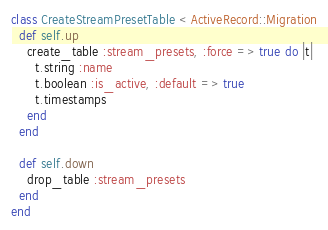Convert code to text. <code><loc_0><loc_0><loc_500><loc_500><_Ruby_>class CreateStreamPresetTable < ActiveRecord::Migration
  def self.up
    create_table :stream_presets, :force => true do |t|
      t.string :name
      t.boolean :is_active, :default => true
      t.timestamps
    end
  end

  def self.down
    drop_table :stream_presets
  end
end

</code> 